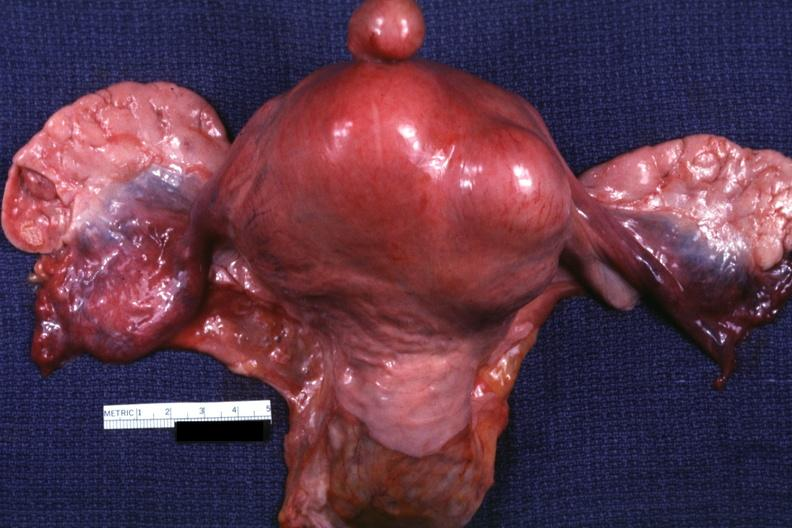s anomalous origin present?
Answer the question using a single word or phrase. No 